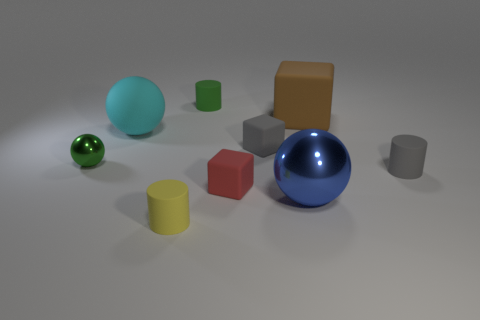Are there any tiny green cylinders made of the same material as the small green sphere?
Keep it short and to the point. No. There is a rubber cylinder that is the same color as the small ball; what size is it?
Give a very brief answer. Small. Are there fewer small gray matte cubes than small rubber things?
Offer a very short reply. Yes. There is a rubber cube that is to the right of the small gray cube; does it have the same color as the tiny shiny sphere?
Your answer should be very brief. No. There is a big sphere that is in front of the small green object in front of the rubber block behind the cyan rubber thing; what is its material?
Your answer should be very brief. Metal. Is there a cube of the same color as the large matte sphere?
Your answer should be very brief. No. Are there fewer tiny green rubber objects in front of the red rubber cube than big green rubber cylinders?
Offer a very short reply. No. There is a green object that is in front of the gray rubber cube; does it have the same size as the big cyan object?
Your answer should be very brief. No. How many things are both behind the tiny gray rubber cube and in front of the green matte cylinder?
Provide a short and direct response. 2. How big is the metal thing that is behind the small block in front of the tiny shiny ball?
Your answer should be very brief. Small. 